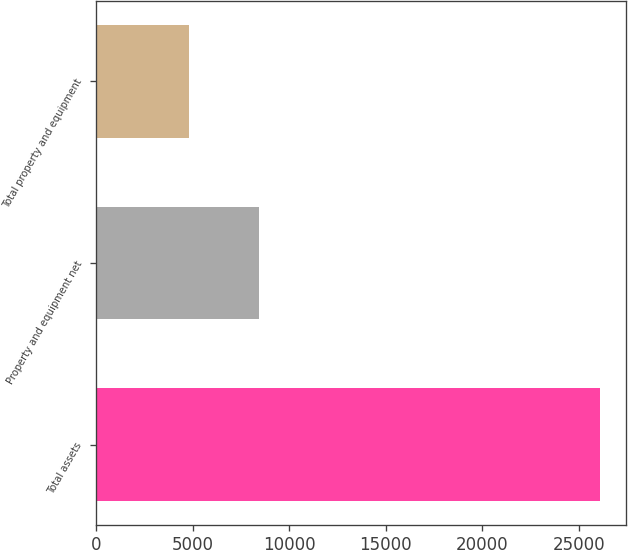Convert chart. <chart><loc_0><loc_0><loc_500><loc_500><bar_chart><fcel>Total assets<fcel>Property and equipment net<fcel>Total property and equipment<nl><fcel>26108<fcel>8447<fcel>4837<nl></chart> 